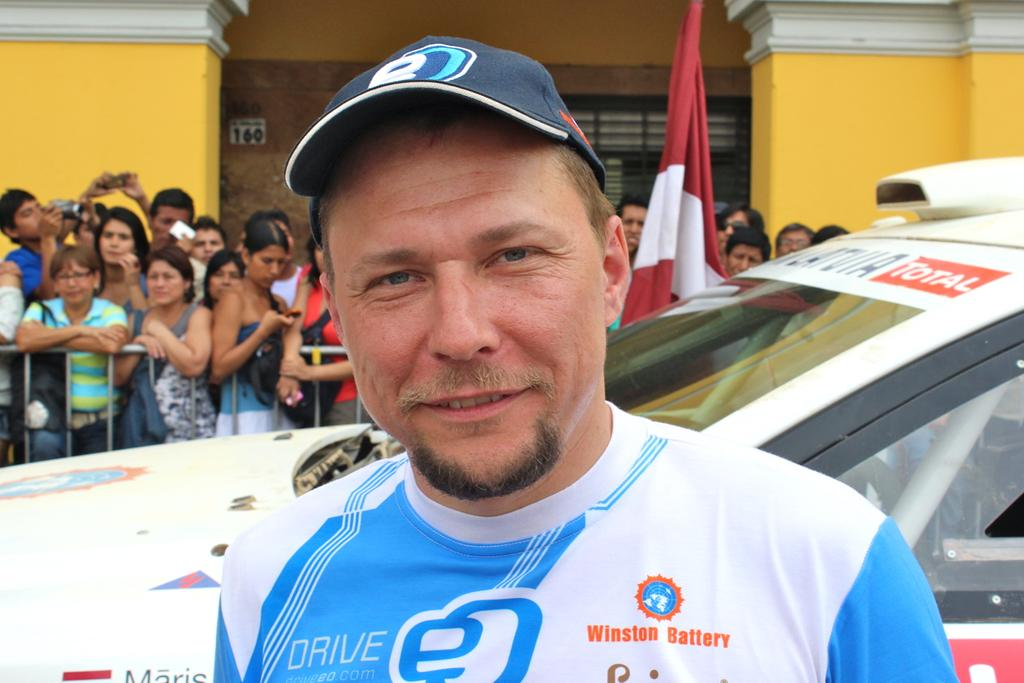What is the person in the image wearing? The person in the image is wearing a blue and white color shirt. What can be seen in the background of the image? There is a white-colored vehicle and other persons standing in the background. What color is the wall in the background? The wall in the background is yellow. How many rings does the grandmother in the image have on her fingers? There is no grandmother present in the image, and therefore no rings can be observed. 